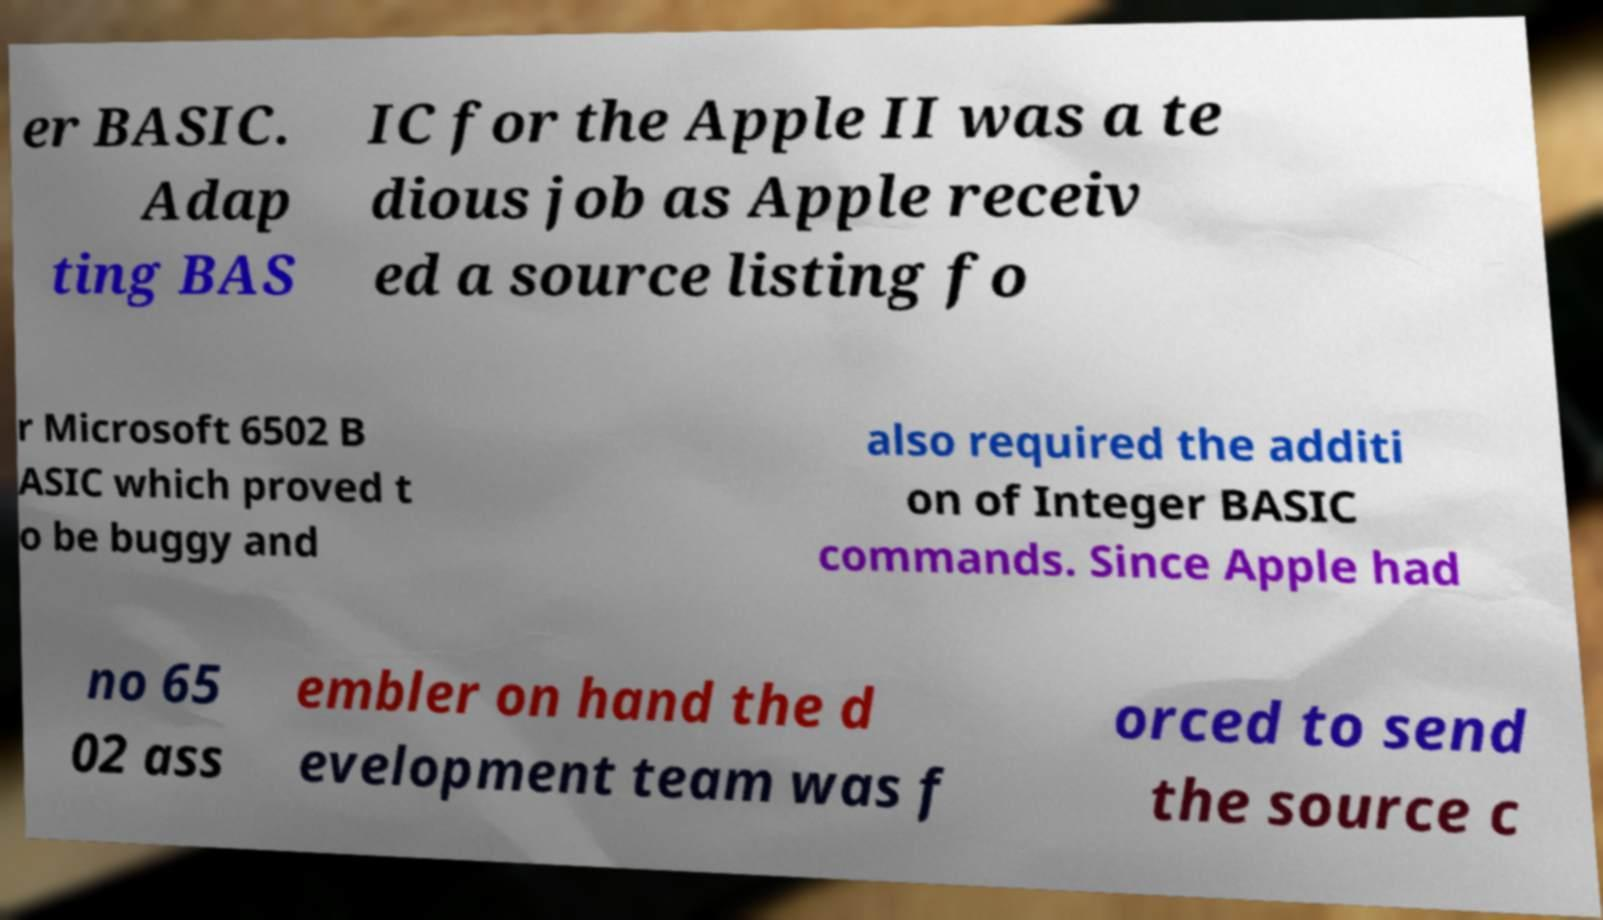Can you read and provide the text displayed in the image?This photo seems to have some interesting text. Can you extract and type it out for me? er BASIC. Adap ting BAS IC for the Apple II was a te dious job as Apple receiv ed a source listing fo r Microsoft 6502 B ASIC which proved t o be buggy and also required the additi on of Integer BASIC commands. Since Apple had no 65 02 ass embler on hand the d evelopment team was f orced to send the source c 